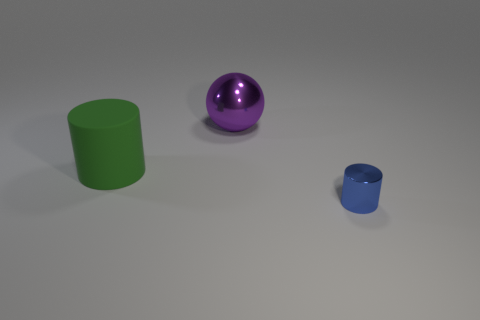Add 1 small green rubber cubes. How many objects exist? 4 Subtract all spheres. How many objects are left? 2 Subtract all cylinders. Subtract all green rubber objects. How many objects are left? 0 Add 3 small metal things. How many small metal things are left? 4 Add 1 green shiny balls. How many green shiny balls exist? 1 Subtract 0 green balls. How many objects are left? 3 